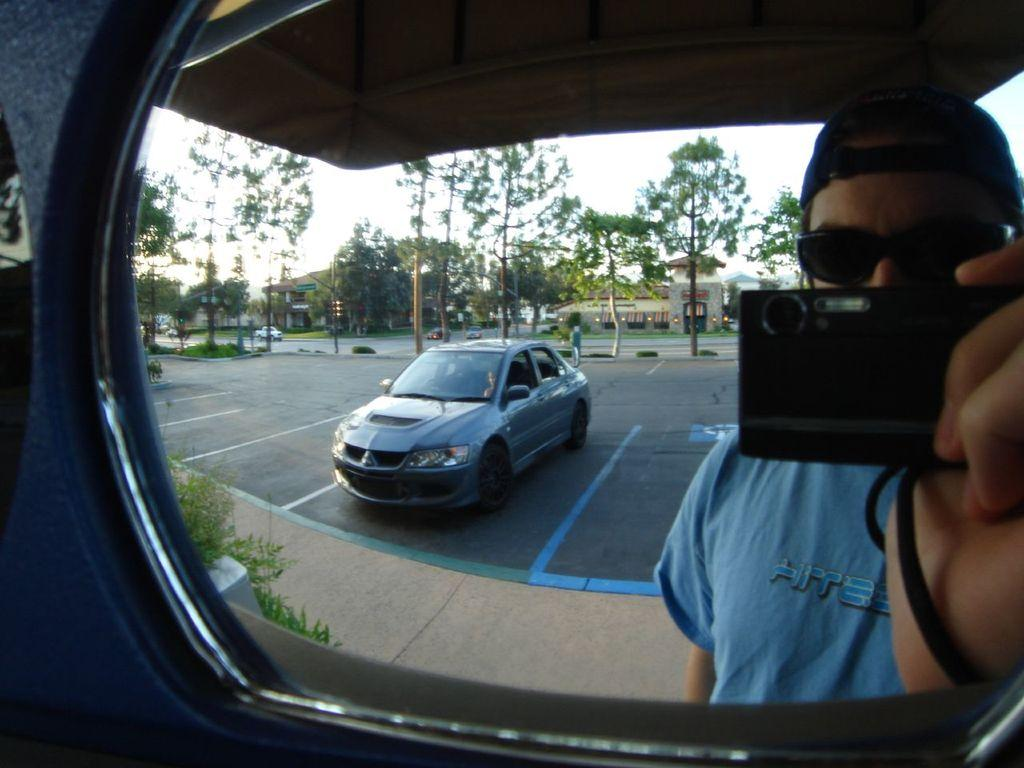What object is in the image that can be used for reflection? There is a mirror in the image. Who is visible in the right corner of the image? A person holding a camera is visible in the right corner of the image. What can be seen in the background of the image? There are vehicles, trees, and buildings in the background of the image. What arithmetic problem is being solved on the mirror in the image? There is no arithmetic problem visible on the mirror in the image. Can you see a friend of the person holding the camera in the image? There is no friend of the person holding the camera visible in the image. 